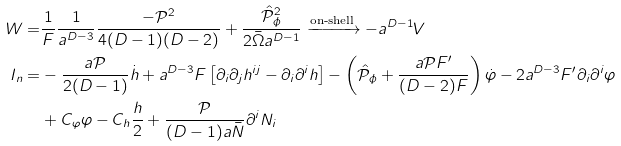<formula> <loc_0><loc_0><loc_500><loc_500>W = & \frac { 1 } { F } \frac { 1 } { a ^ { D - 3 } } \frac { - \mathcal { P } ^ { 2 } } { 4 ( D - 1 ) ( D - 2 ) } + \frac { \hat { \mathcal { P } } _ { \phi } ^ { 2 } } { 2 \bar { \Omega } a ^ { D - 1 } } \xrightarrow { \text {on-shell} } - a ^ { D - 1 } V \\ I _ { n } = & - \frac { a \mathcal { P } } { 2 ( D - 1 ) } \dot { h } + a ^ { D - 3 } F \left [ \partial _ { i } \partial _ { j } h ^ { i j } - \partial _ { i } \partial ^ { i } h \right ] - \left ( \hat { \mathcal { P } } _ { \phi } + \frac { a \mathcal { P } F ^ { \prime } } { ( D - 2 ) F } \right ) \dot { \varphi } - 2 a ^ { D - 3 } F ^ { \prime } \partial _ { i } \partial ^ { i } \varphi \\ & + C _ { \varphi } \varphi - C _ { h } \frac { h } { 2 } + \frac { \mathcal { P } } { ( D - 1 ) a \bar { N } } \partial ^ { i } N _ { i }</formula> 